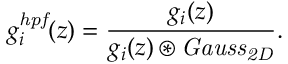Convert formula to latex. <formula><loc_0><loc_0><loc_500><loc_500>g _ { i } ^ { h p f } ( z ) = \frac { g _ { i } ( z ) } { g _ { i } ( z ) \circledast G a u s s _ { 2 D } } .</formula> 